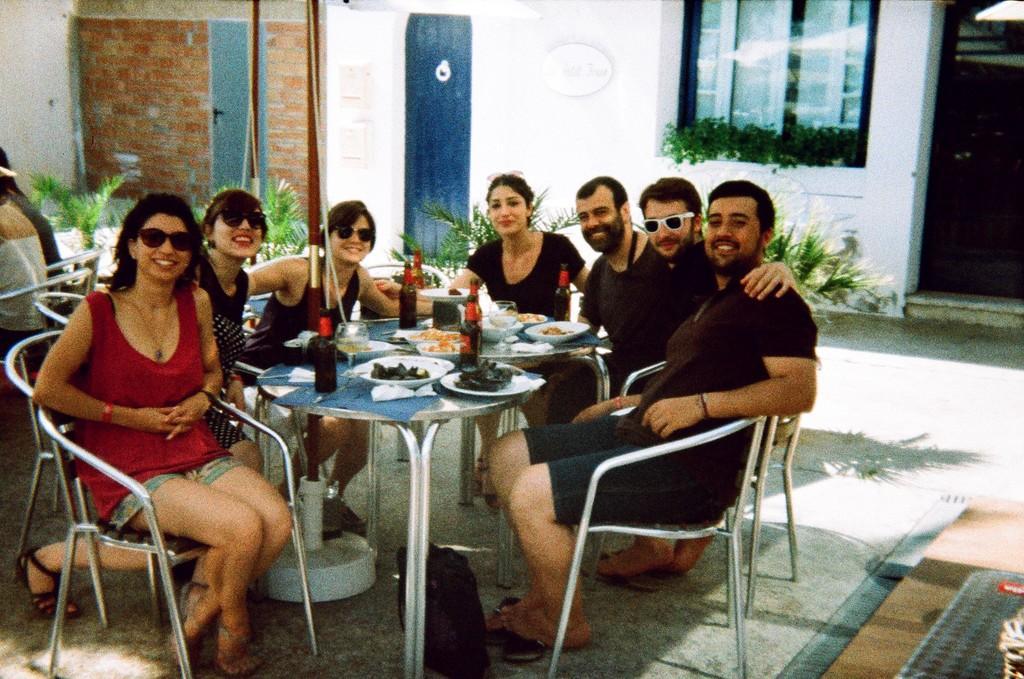Describe this image in one or two sentences. In this image I can see a few people are sitting on the chairs, smiling and giving pose to the picture. In the middle of this person's there is a table. On the table I can see few bowls with food items,bottles and glasses. In the background there is a wall and plants. 